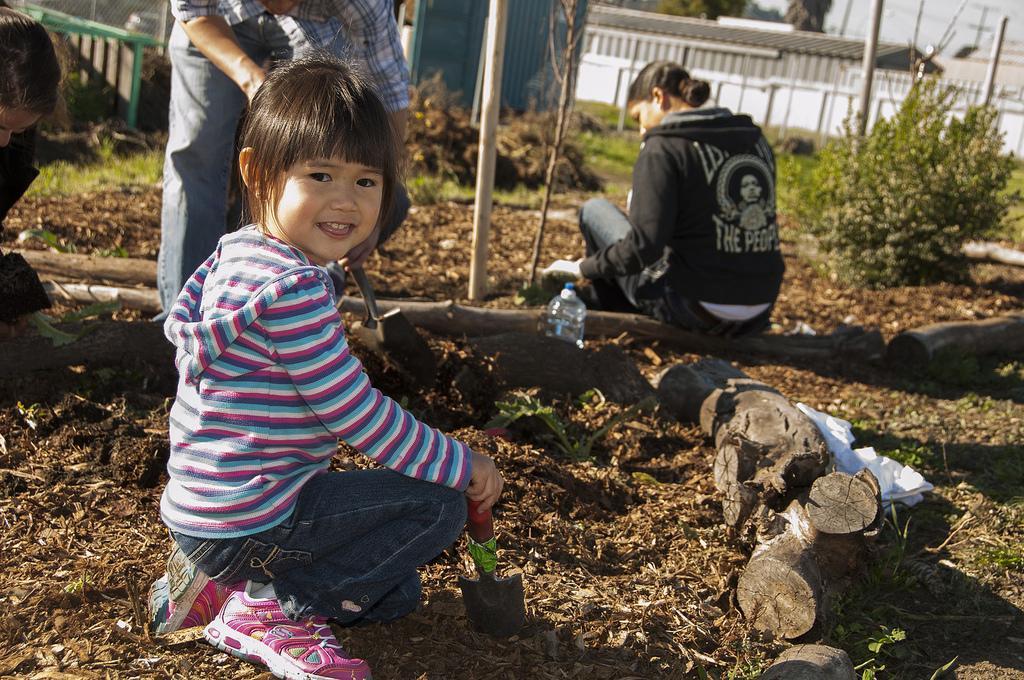Describe this image in one or two sentences. In the image there are few people doing some work by sitting on the ground and around them there are wooden logs and plants, in the background there is a wall. 